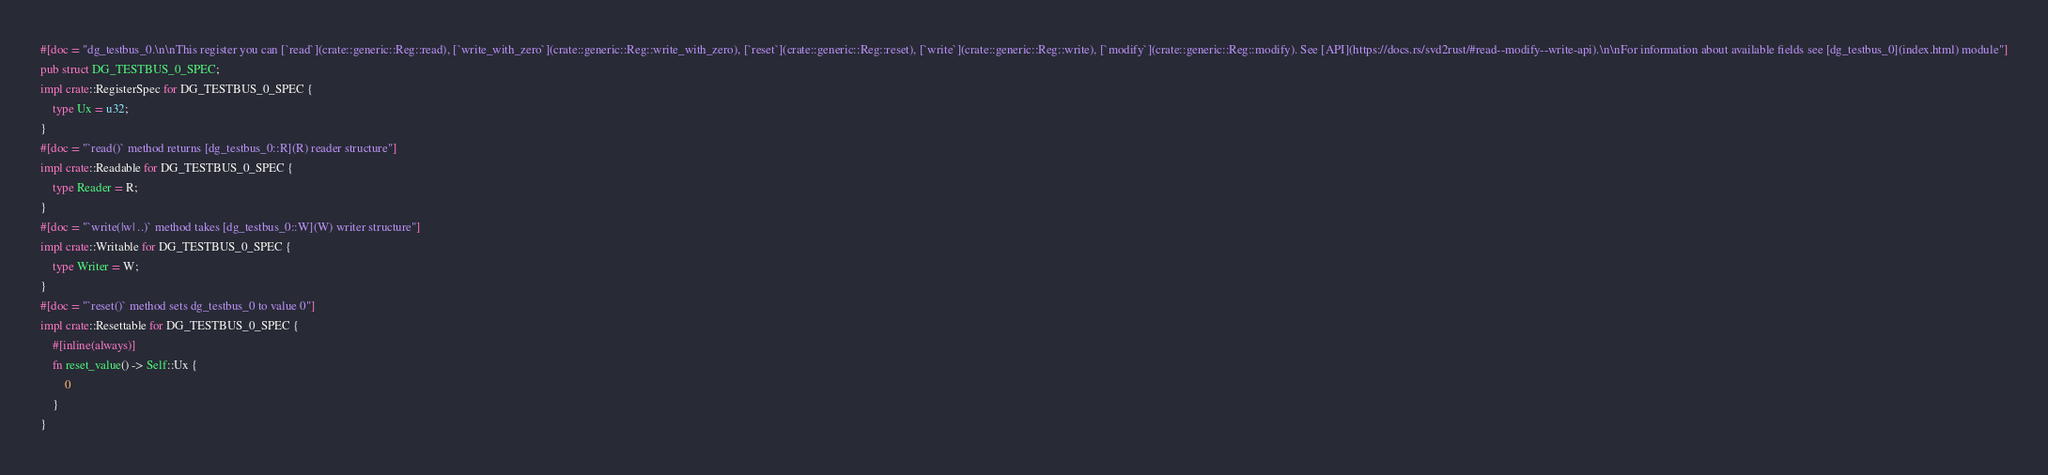<code> <loc_0><loc_0><loc_500><loc_500><_Rust_>#[doc = "dg_testbus_0.\n\nThis register you can [`read`](crate::generic::Reg::read), [`write_with_zero`](crate::generic::Reg::write_with_zero), [`reset`](crate::generic::Reg::reset), [`write`](crate::generic::Reg::write), [`modify`](crate::generic::Reg::modify). See [API](https://docs.rs/svd2rust/#read--modify--write-api).\n\nFor information about available fields see [dg_testbus_0](index.html) module"]
pub struct DG_TESTBUS_0_SPEC;
impl crate::RegisterSpec for DG_TESTBUS_0_SPEC {
    type Ux = u32;
}
#[doc = "`read()` method returns [dg_testbus_0::R](R) reader structure"]
impl crate::Readable for DG_TESTBUS_0_SPEC {
    type Reader = R;
}
#[doc = "`write(|w| ..)` method takes [dg_testbus_0::W](W) writer structure"]
impl crate::Writable for DG_TESTBUS_0_SPEC {
    type Writer = W;
}
#[doc = "`reset()` method sets dg_testbus_0 to value 0"]
impl crate::Resettable for DG_TESTBUS_0_SPEC {
    #[inline(always)]
    fn reset_value() -> Self::Ux {
        0
    }
}
</code> 